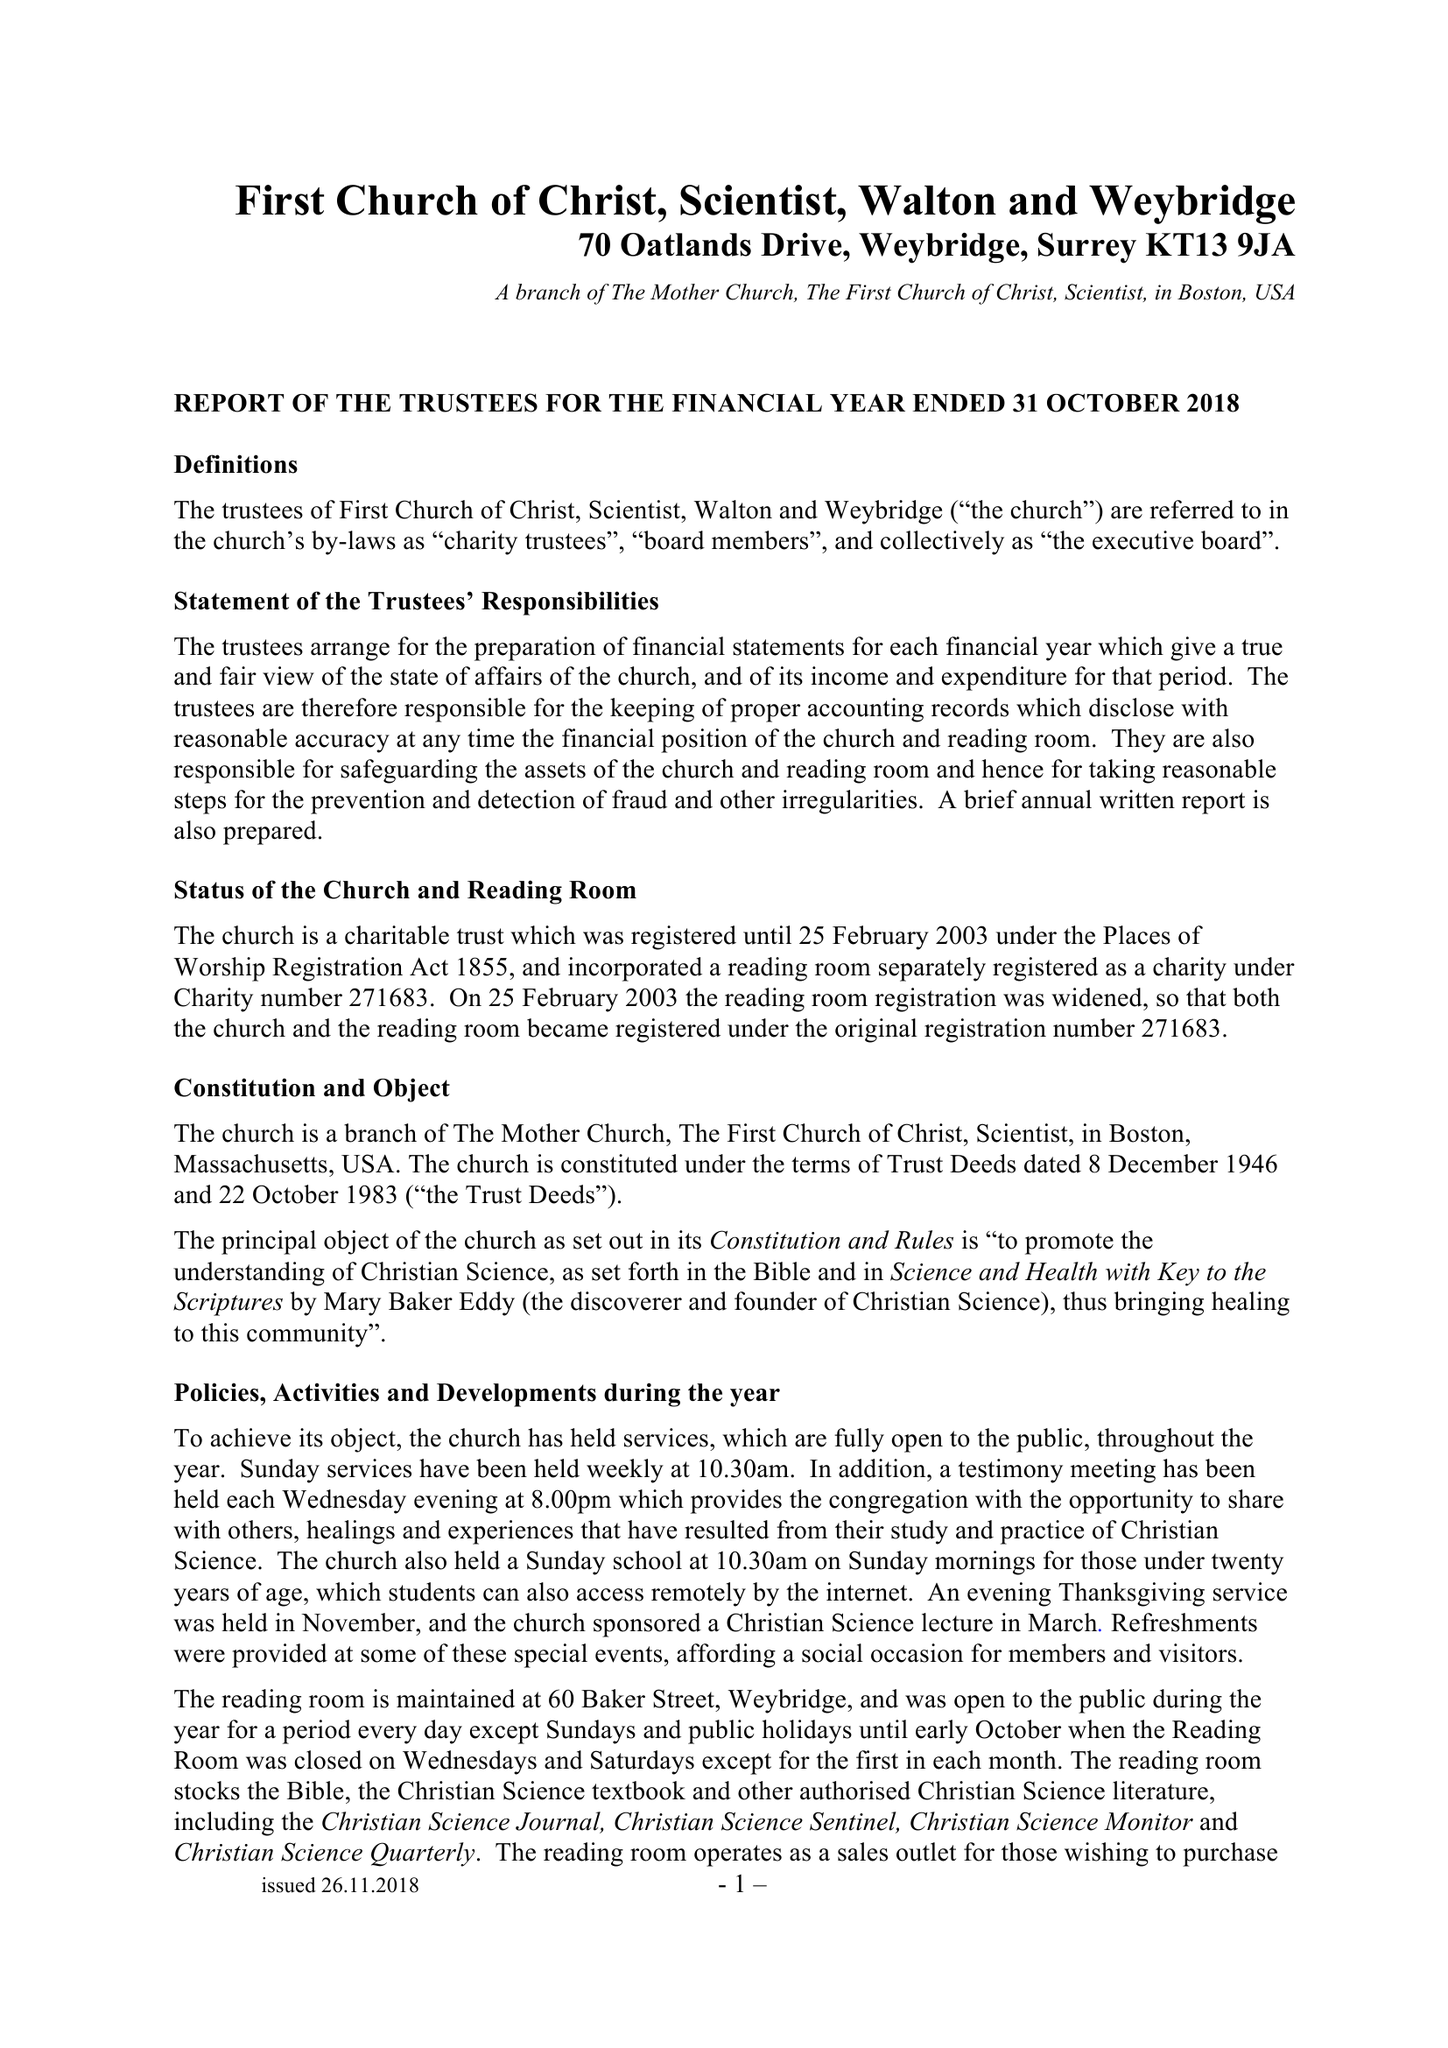What is the value for the income_annually_in_british_pounds?
Answer the question using a single word or phrase. 51658.00 